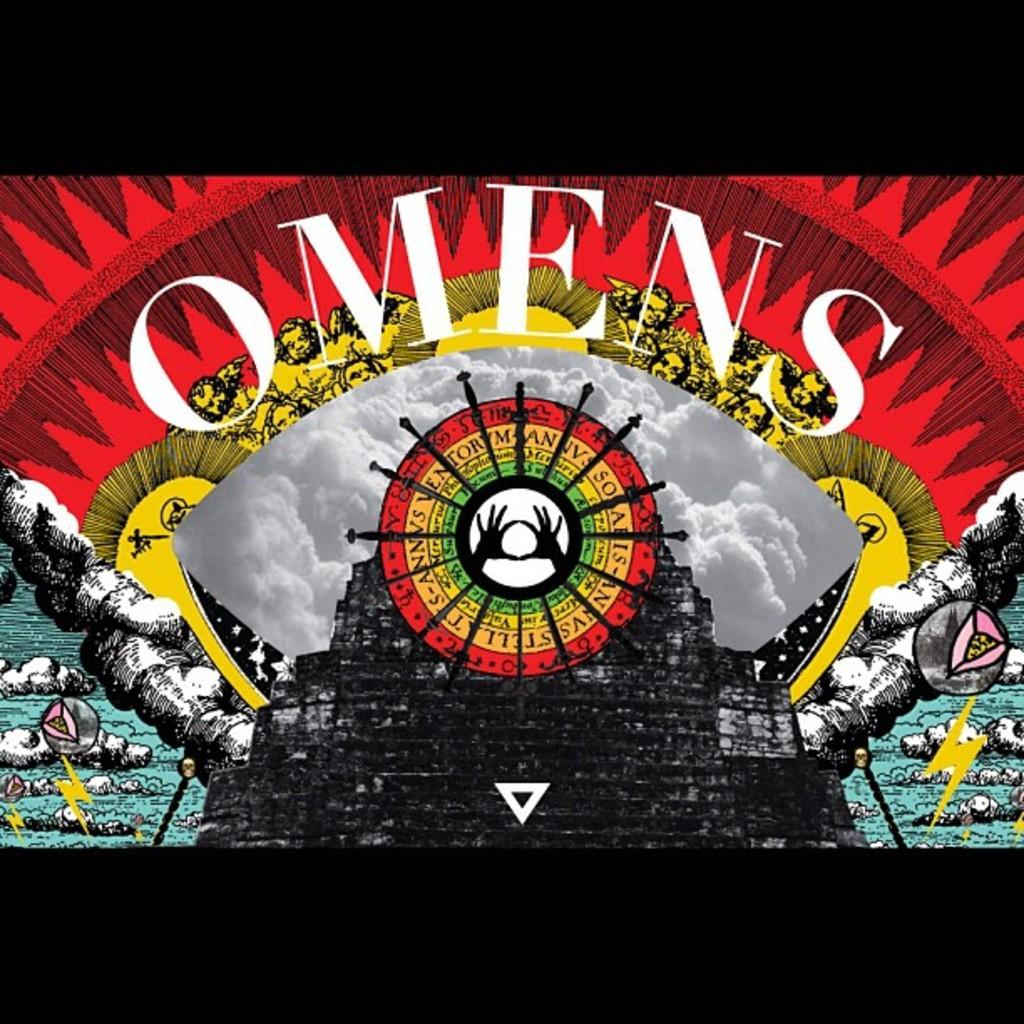Provide a one-sentence caption for the provided image. A surreal piece of art with many different elements such as clouds and faces with the word omens printed on it. 